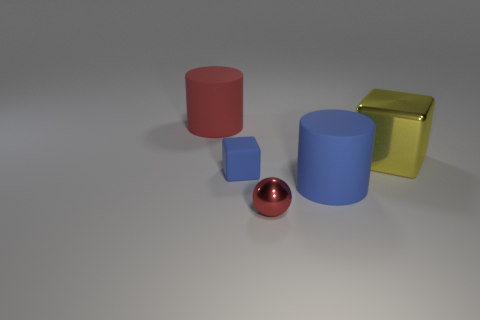Add 1 small blue rubber blocks. How many objects exist? 6 Subtract all blocks. How many objects are left? 3 Subtract all purple cubes. How many green cylinders are left? 0 Subtract all small blue matte blocks. Subtract all yellow cylinders. How many objects are left? 4 Add 3 blue blocks. How many blue blocks are left? 4 Add 3 small blue blocks. How many small blue blocks exist? 4 Subtract 1 blue cubes. How many objects are left? 4 Subtract all red blocks. Subtract all red spheres. How many blocks are left? 2 